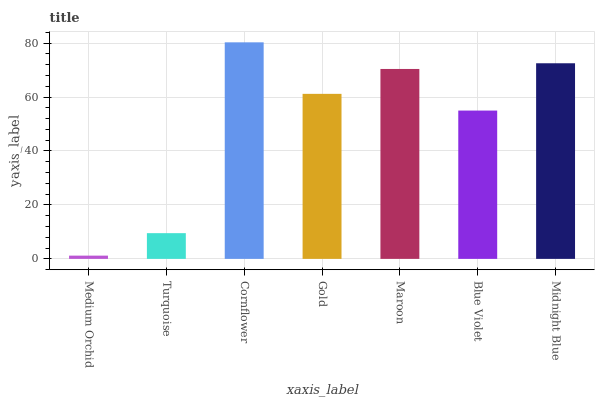Is Medium Orchid the minimum?
Answer yes or no. Yes. Is Cornflower the maximum?
Answer yes or no. Yes. Is Turquoise the minimum?
Answer yes or no. No. Is Turquoise the maximum?
Answer yes or no. No. Is Turquoise greater than Medium Orchid?
Answer yes or no. Yes. Is Medium Orchid less than Turquoise?
Answer yes or no. Yes. Is Medium Orchid greater than Turquoise?
Answer yes or no. No. Is Turquoise less than Medium Orchid?
Answer yes or no. No. Is Gold the high median?
Answer yes or no. Yes. Is Gold the low median?
Answer yes or no. Yes. Is Medium Orchid the high median?
Answer yes or no. No. Is Turquoise the low median?
Answer yes or no. No. 